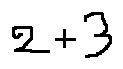Convert formula to latex. <formula><loc_0><loc_0><loc_500><loc_500>2 + 3</formula> 